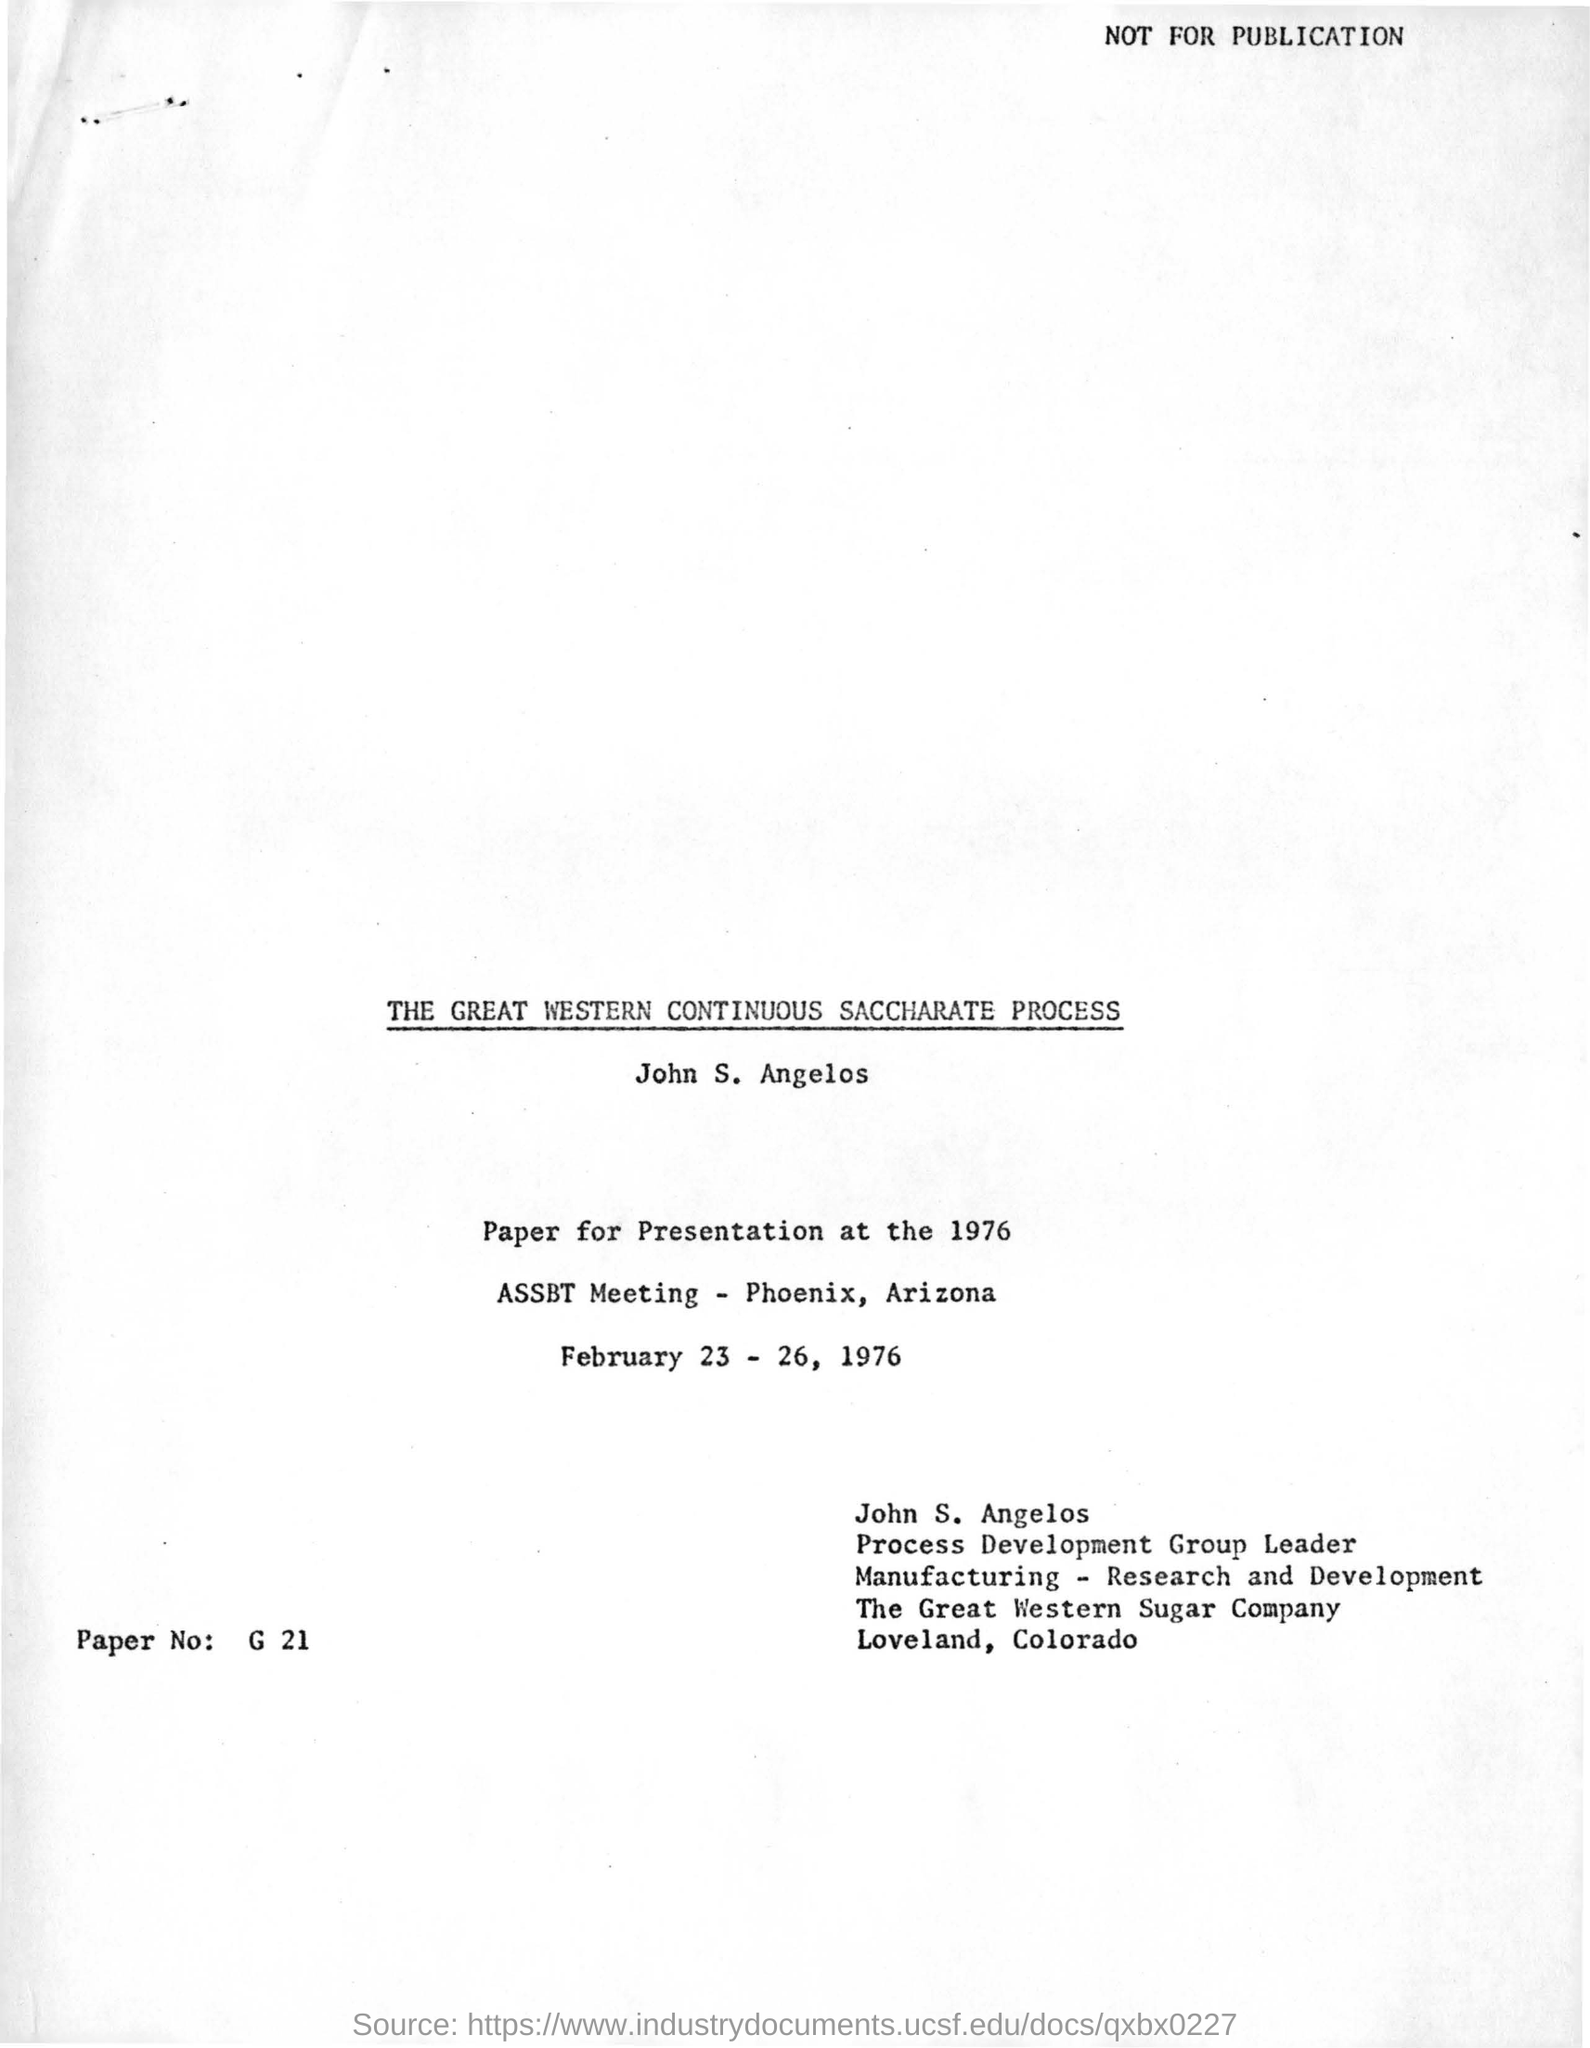Where is the location of assbt meeting?
Keep it short and to the point. Phoenix, Arizona. Who is the process development group leader?
Offer a very short reply. John s. Angelos. Where is the location of great western sugar company?
Make the answer very short. Loveland, colorado. What is the title of this presentation by john s.angelos?
Make the answer very short. The great western continuous saccharate process. 